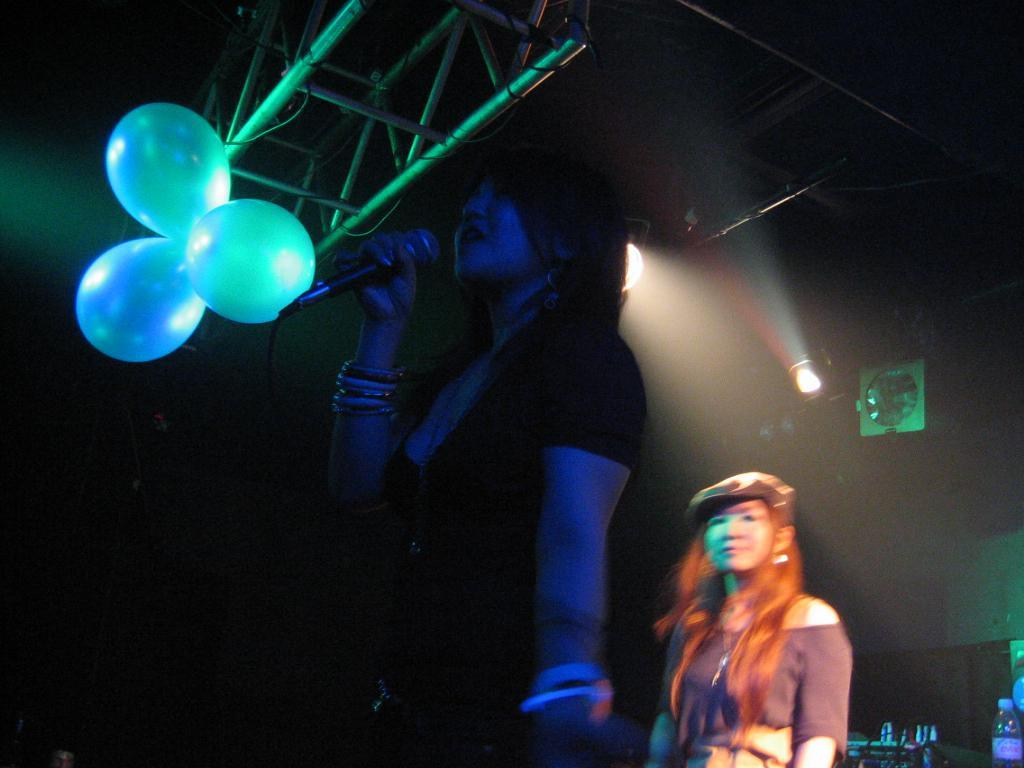What is the person holding in the image? The person is holding a microphone in the image. Can you describe the other person in the image? There is another person standing in the image. What decorative items can be seen in the image? There are balloons in the image. What type of lighting is present in the image? There are focus lights in the image. What is the shape of the bottle in the image? The shape of the bottle cannot be determined from the image. What other objects are present in the image? There are other objects present in the image, but their specific details are not mentioned in the facts. What type of seed is being planted by the person holding the wrench in the image? There is no person holding a wrench or planting seeds in the image. 